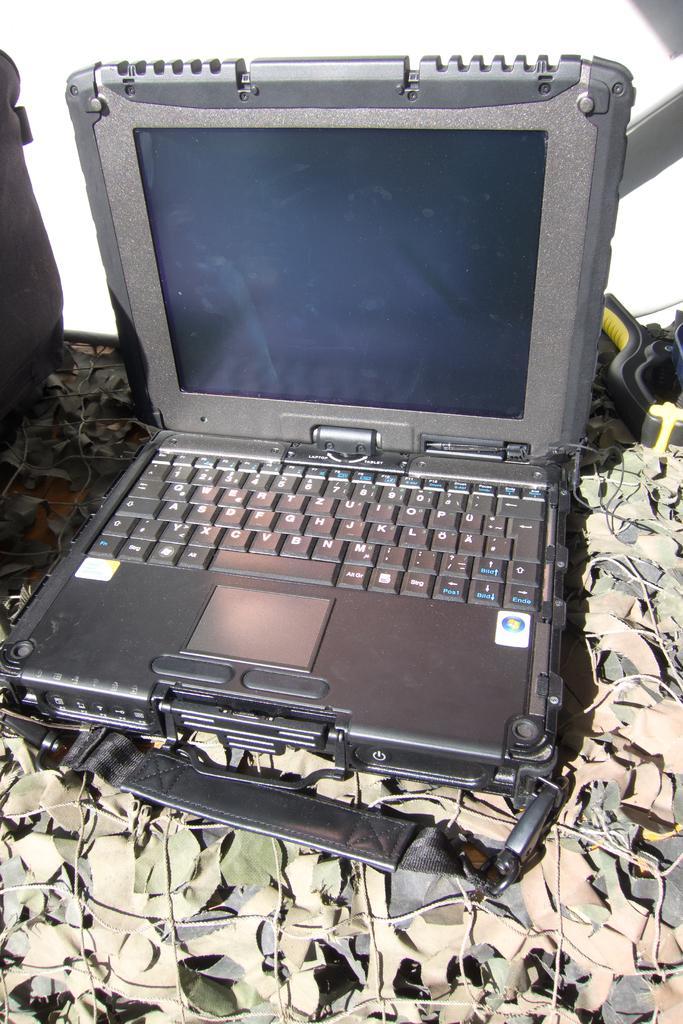Describe this image in one or two sentences. In this image I can see a laptop in the front and both side of it I can see few stuffs. I can also see white colour in the background. 